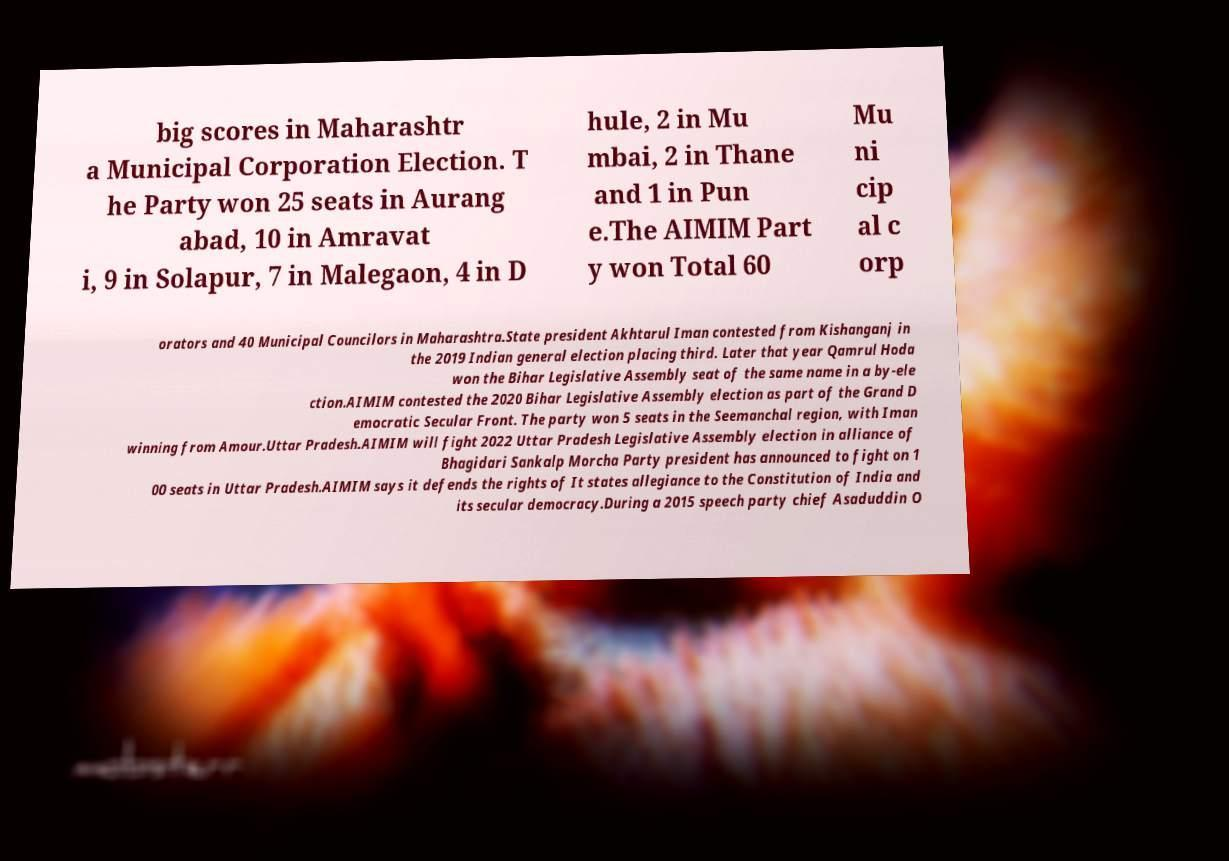I need the written content from this picture converted into text. Can you do that? big scores in Maharashtr a Municipal Corporation Election. T he Party won 25 seats in Aurang abad, 10 in Amravat i, 9 in Solapur, 7 in Malegaon, 4 in D hule, 2 in Mu mbai, 2 in Thane and 1 in Pun e.The AIMIM Part y won Total 60 Mu ni cip al c orp orators and 40 Municipal Councilors in Maharashtra.State president Akhtarul Iman contested from Kishanganj in the 2019 Indian general election placing third. Later that year Qamrul Hoda won the Bihar Legislative Assembly seat of the same name in a by-ele ction.AIMIM contested the 2020 Bihar Legislative Assembly election as part of the Grand D emocratic Secular Front. The party won 5 seats in the Seemanchal region, with Iman winning from Amour.Uttar Pradesh.AIMIM will fight 2022 Uttar Pradesh Legislative Assembly election in alliance of Bhagidari Sankalp Morcha Party president has announced to fight on 1 00 seats in Uttar Pradesh.AIMIM says it defends the rights of It states allegiance to the Constitution of India and its secular democracy.During a 2015 speech party chief Asaduddin O 